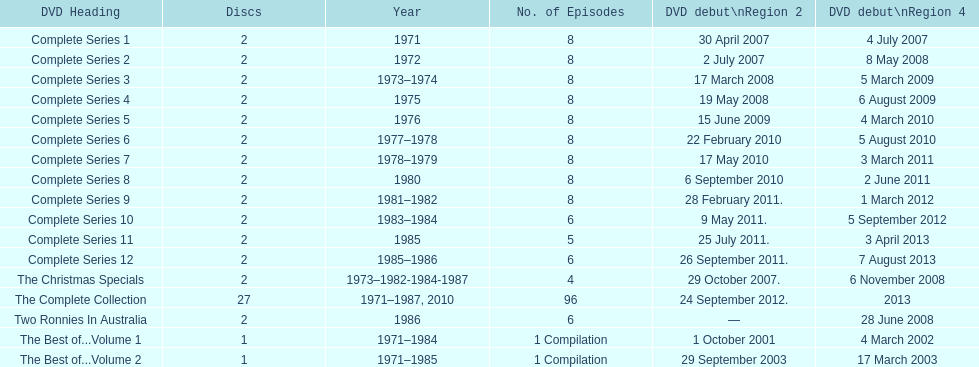True or false. the television show "the two ronnies" featured more than 10 episodes in a season. False. 